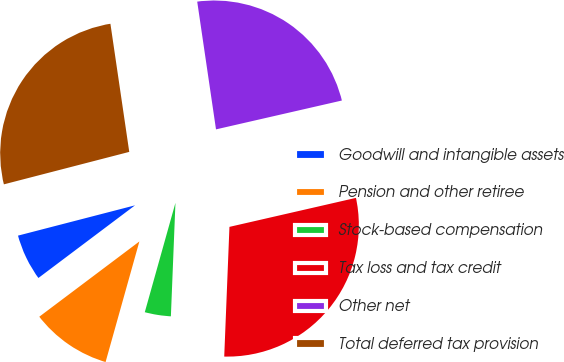Convert chart to OTSL. <chart><loc_0><loc_0><loc_500><loc_500><pie_chart><fcel>Goodwill and intangible assets<fcel>Pension and other retiree<fcel>Stock-based compensation<fcel>Tax loss and tax credit<fcel>Other net<fcel>Total deferred tax provision<nl><fcel>6.23%<fcel>10.39%<fcel>3.71%<fcel>29.23%<fcel>23.74%<fcel>26.71%<nl></chart> 